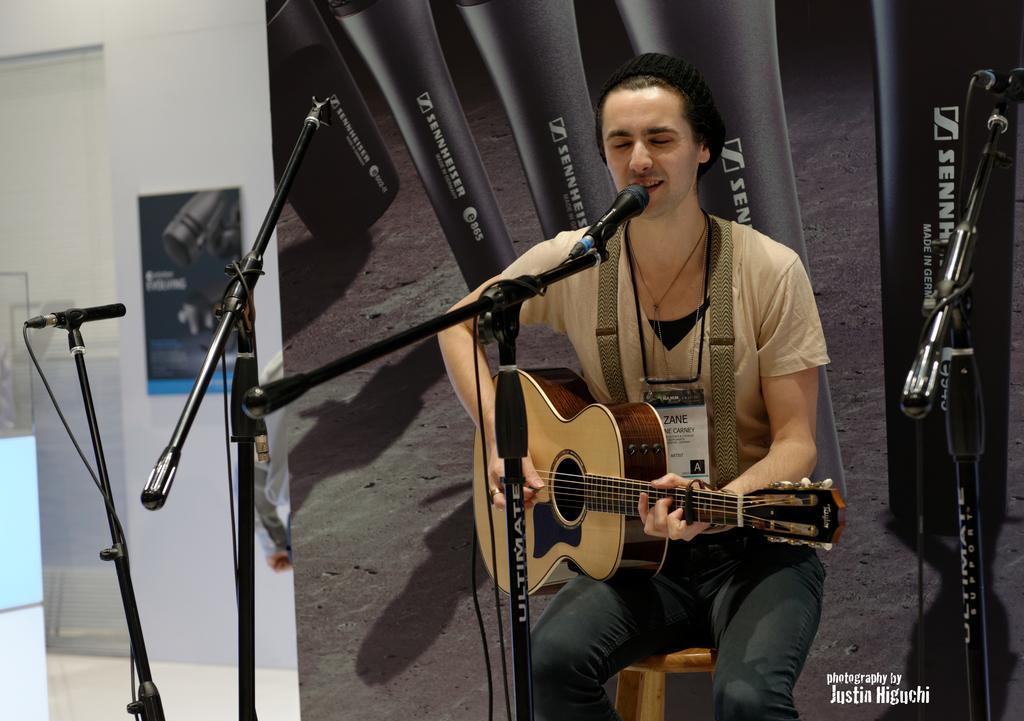What is the man in the image doing? The man is sitting on a stool, playing a guitar, and singing. What object is the man using to amplify his voice? There is a microphone (mic) in the image. What is the man leaning against? There is a stand in the image. What can be seen in the background of the image? There is an image and a wall in the background. What surface is the man sitting on? There is a floor in the image. What type of bread is the man using to play the guitar in the image? There is no bread present in the image, and the man is using a guitar, not bread, to play music. 